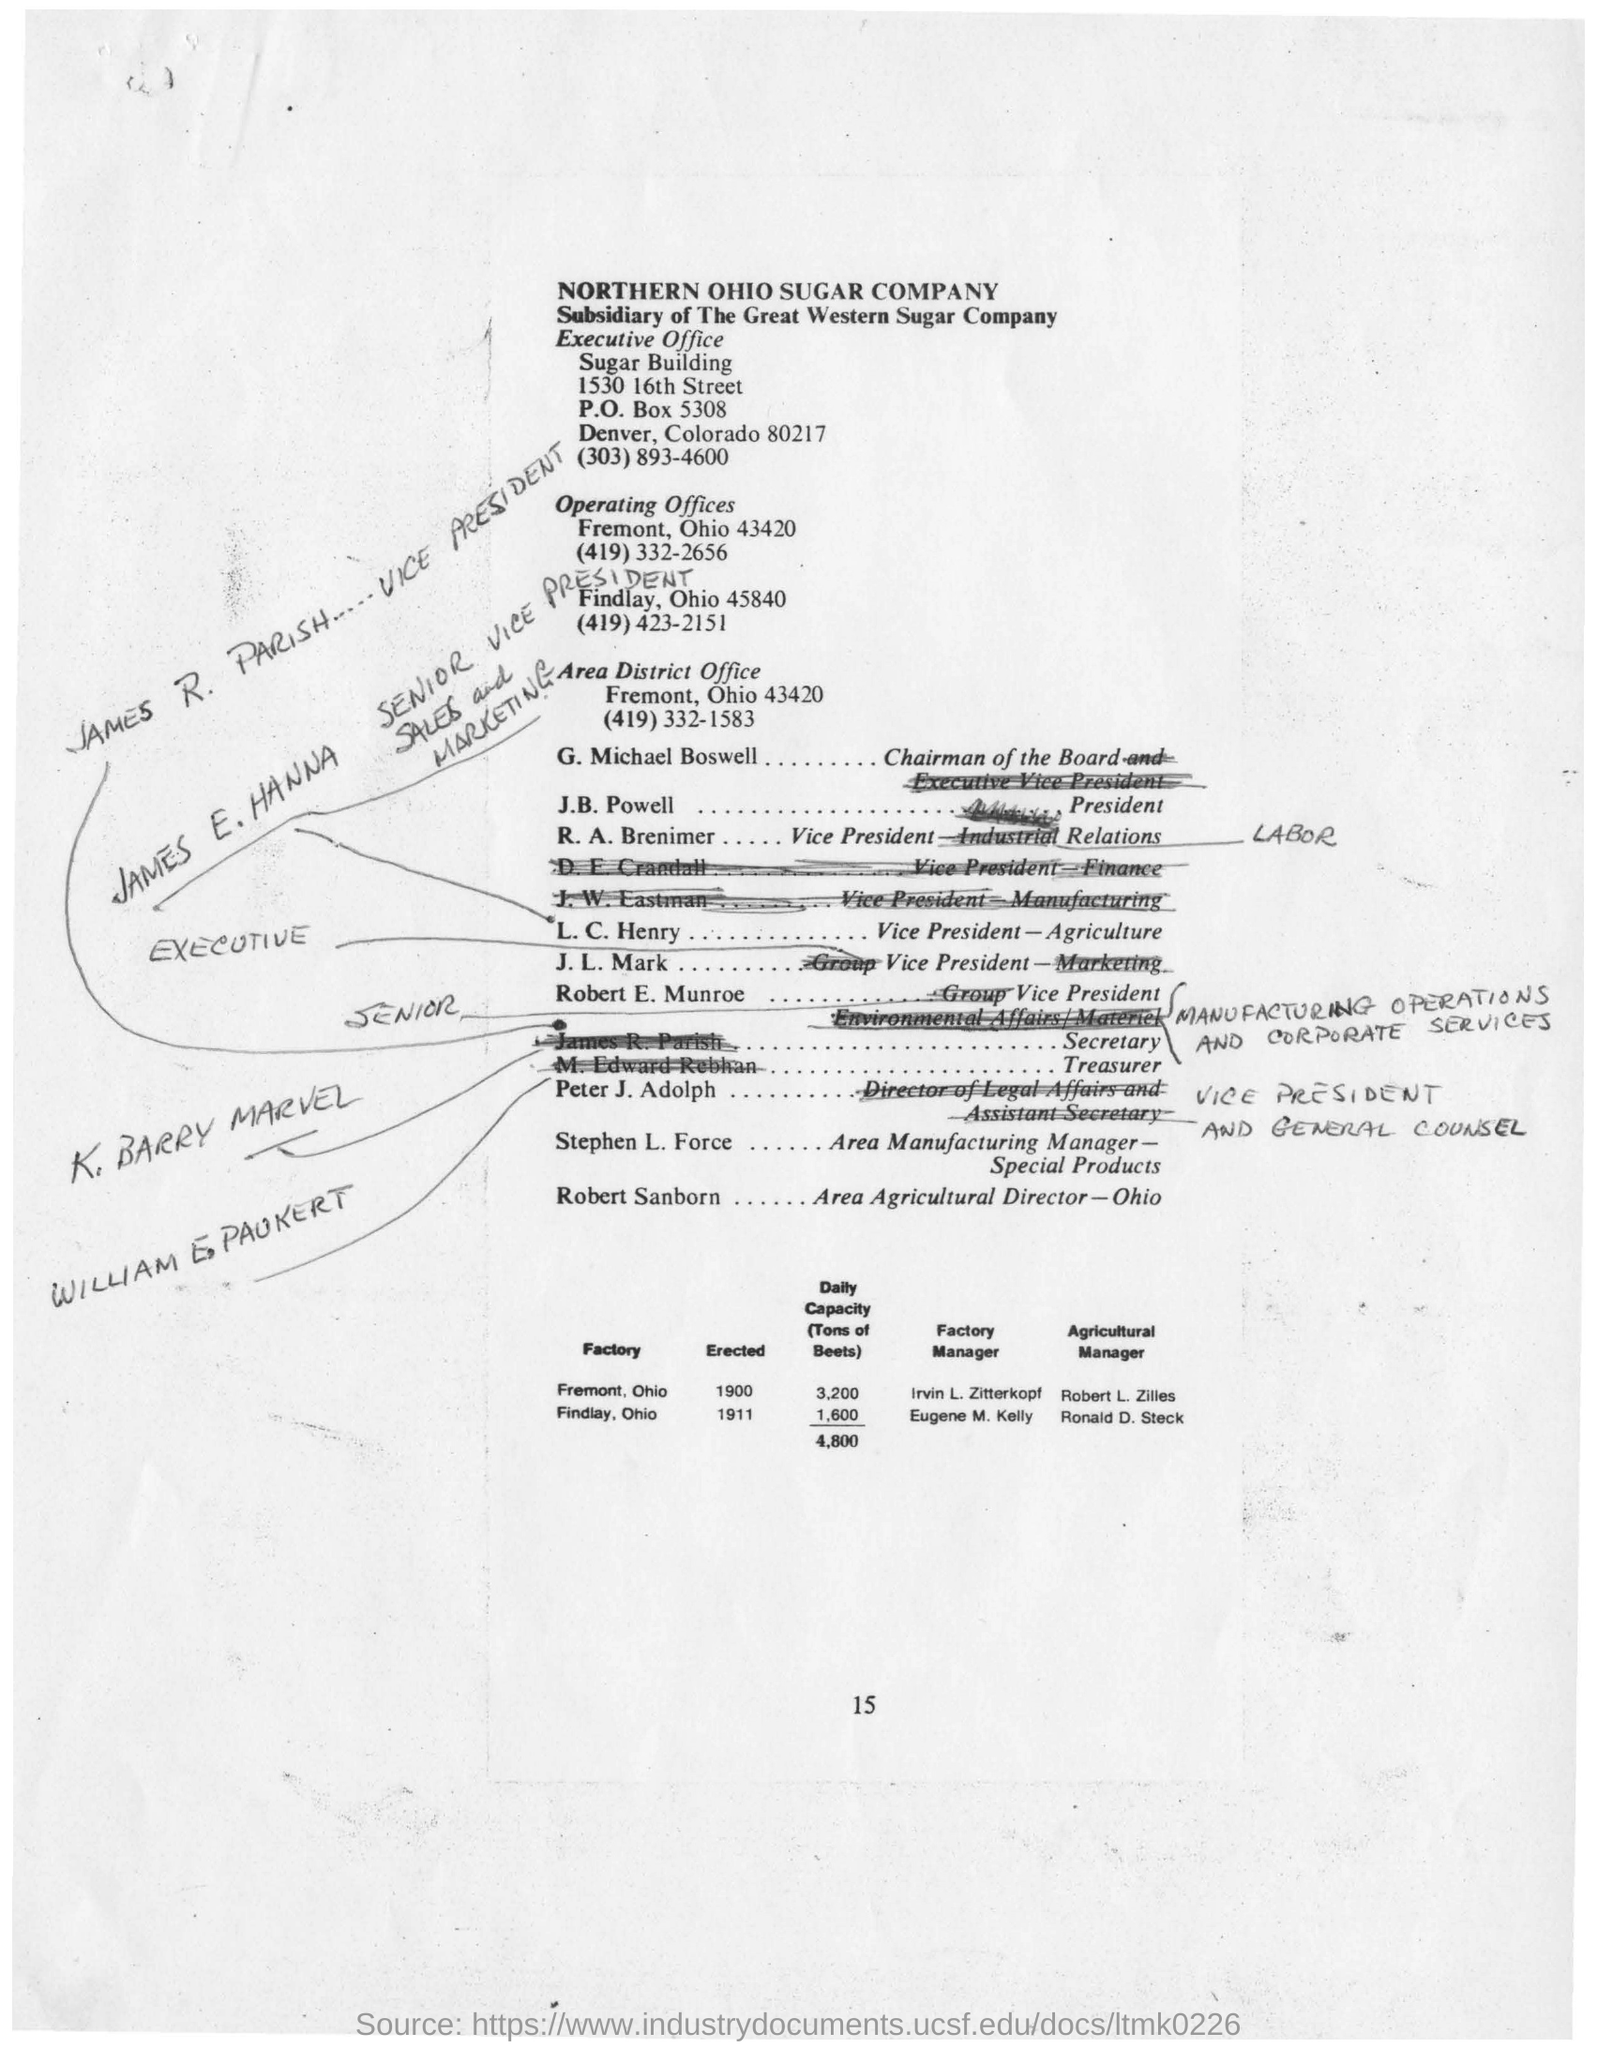Point out several critical features in this image. The Area District Office is located in Fremont, Ohio, at 43420. G. Michael Boswell is the Chairman of the Board. The telephone number of the Executive Office is (303)893-4600. Northern Ohio Sugar Company is a subsidiary of The Great Western Sugar Company. 